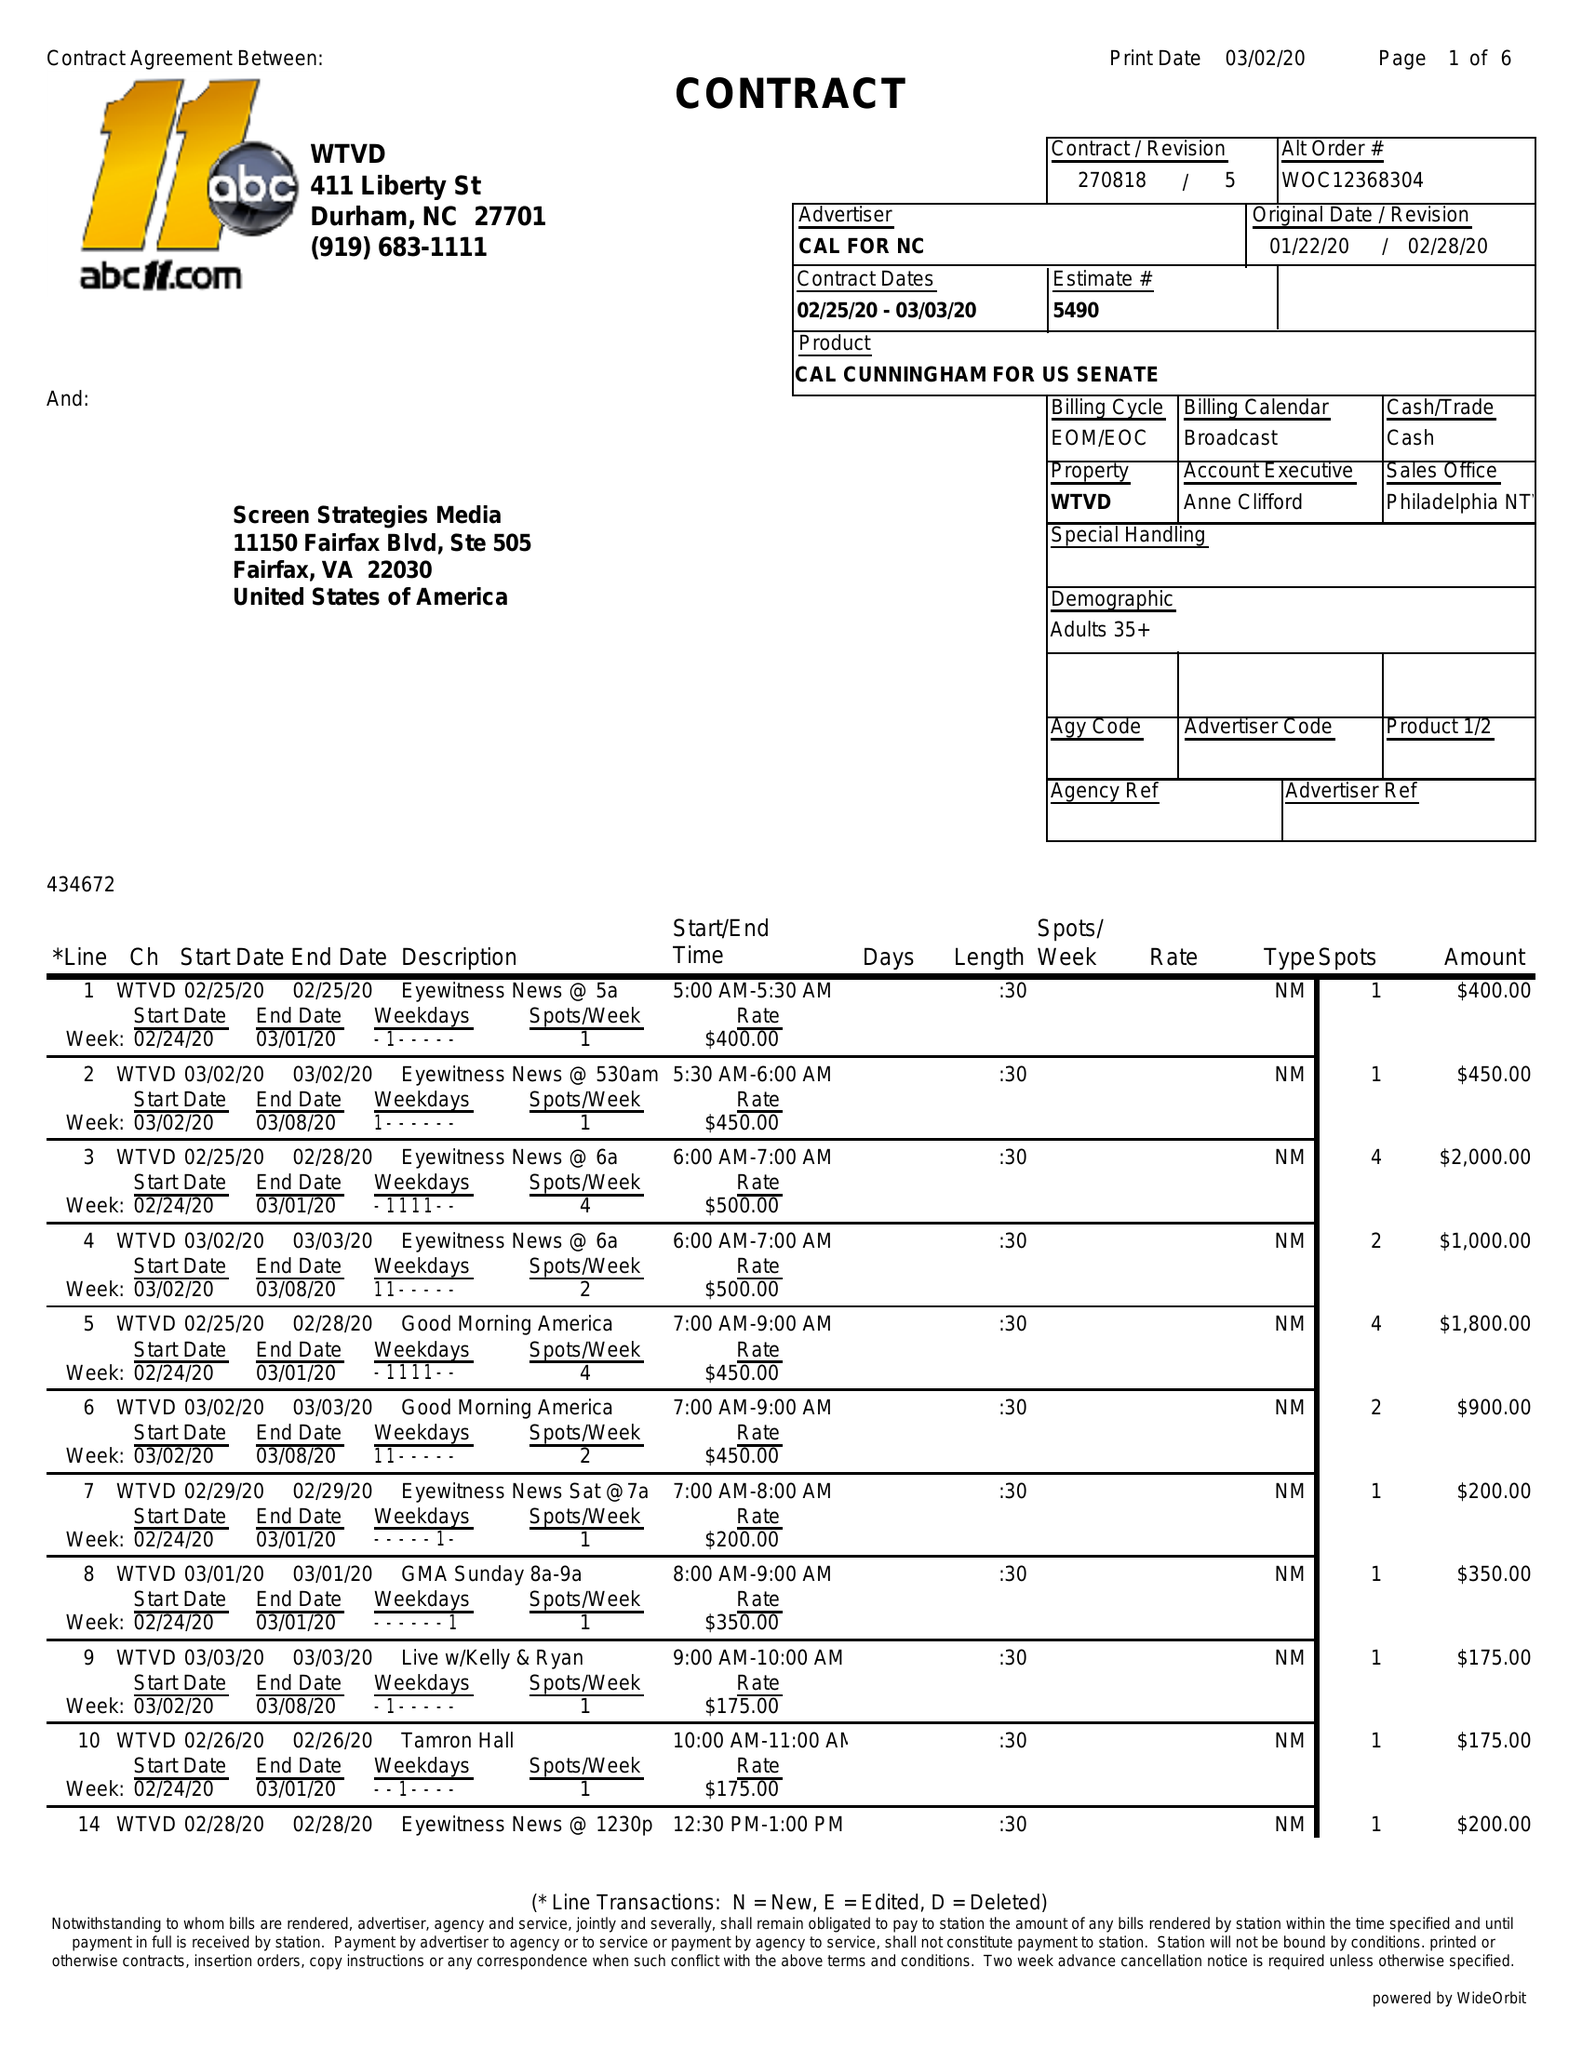What is the value for the gross_amount?
Answer the question using a single word or phrase. 37075.00 